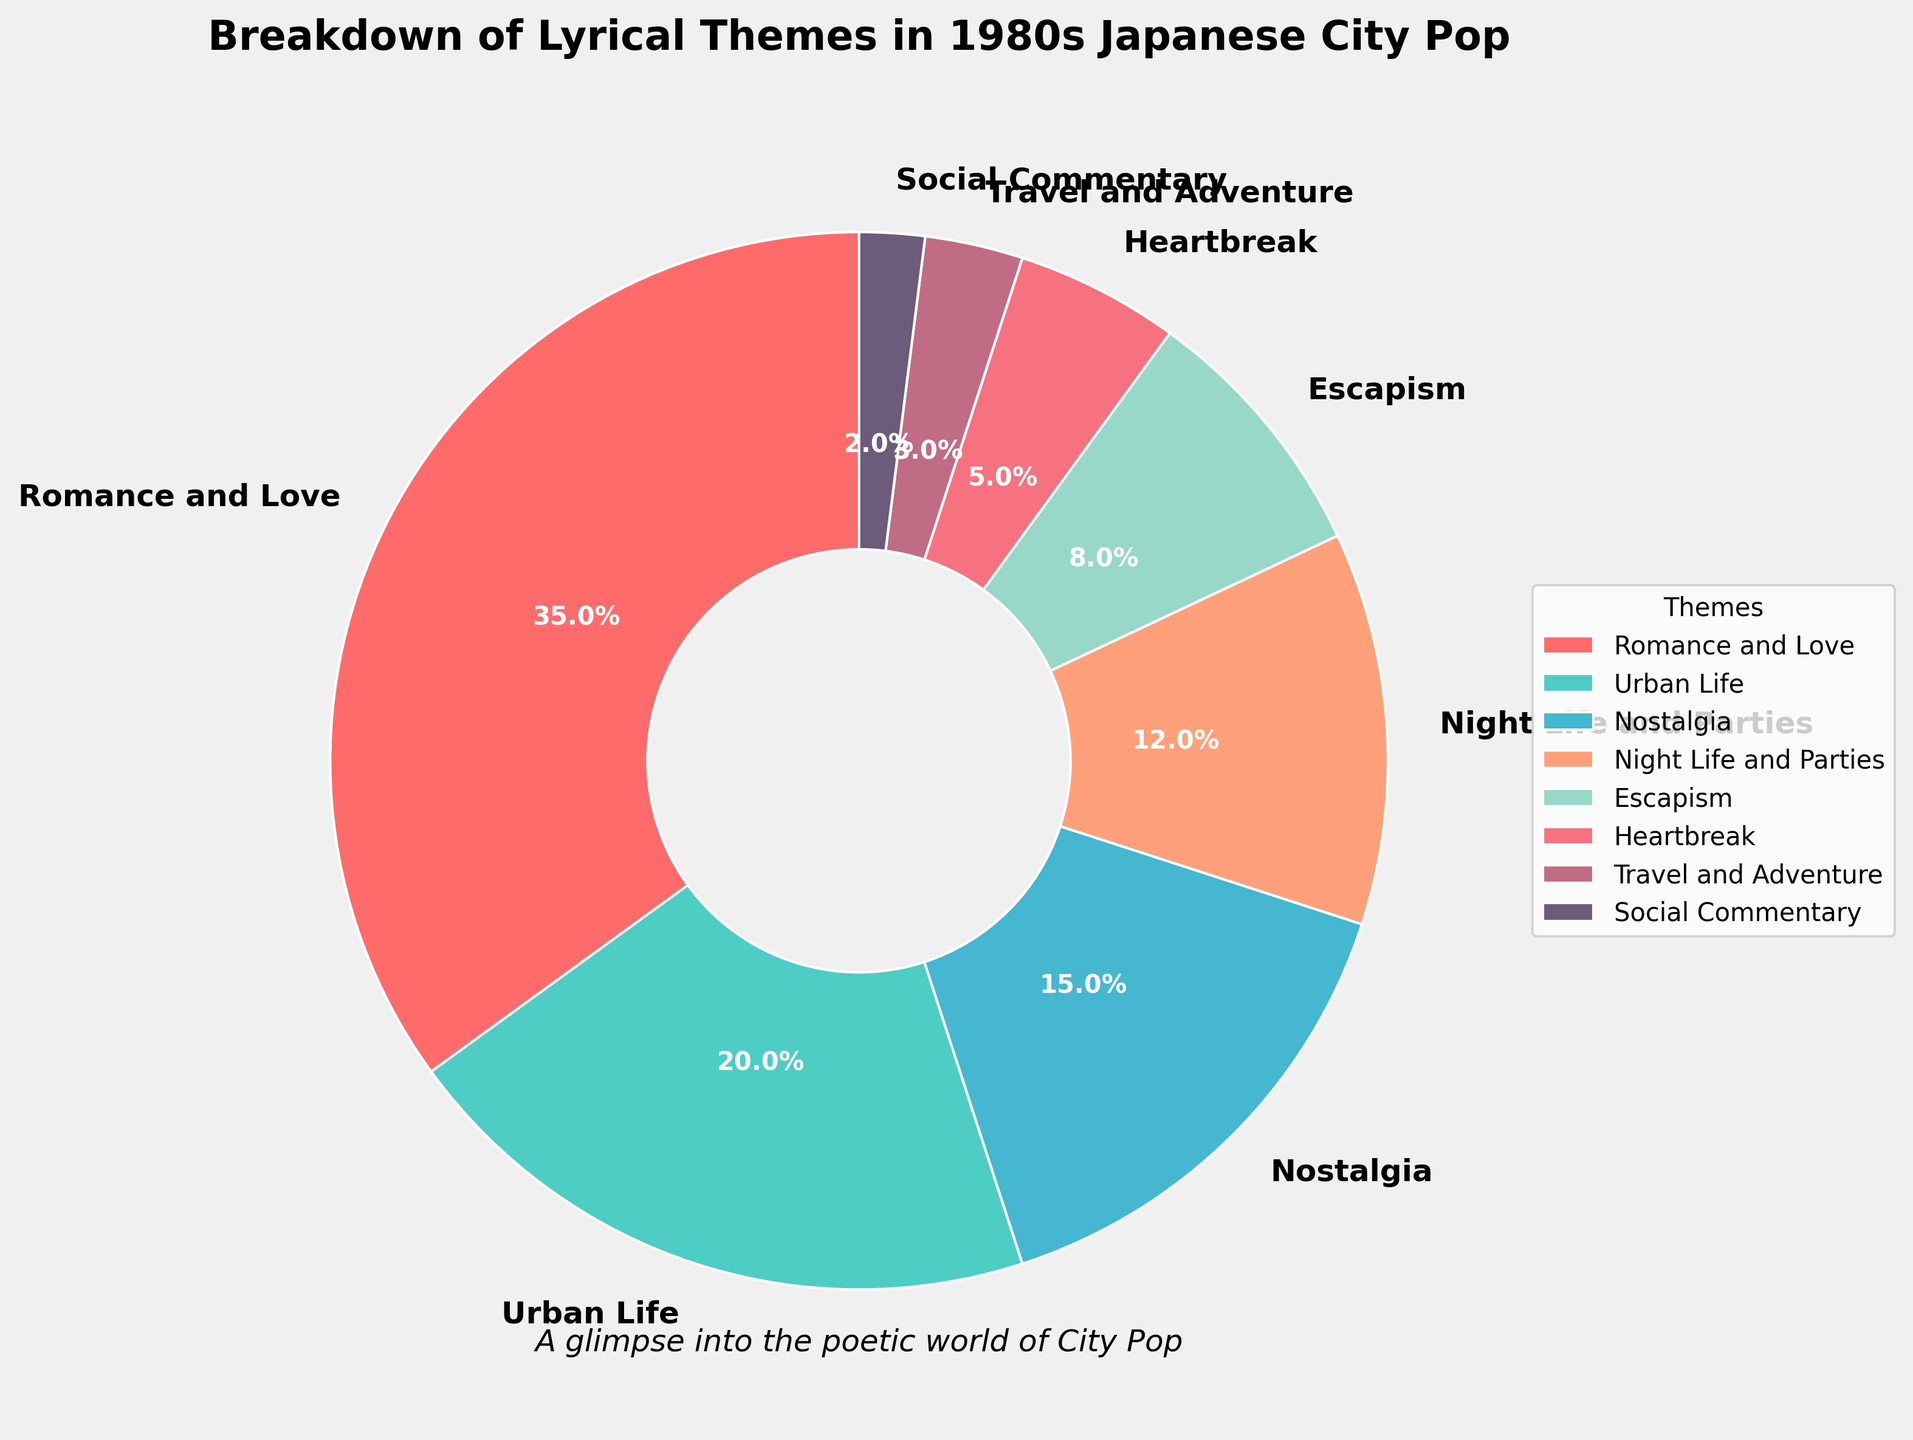What percentage of the lyrical themes are related to both Urban Life and Social Commentary combined? Add the percentages for Urban Life (20%) and Social Commentary (2%). So, 20% + 2% = 22%.
Answer: 22% Which theme has a smaller percentage, Heartbreak or Travel and Adventure? Compare the percentages for Heartbreak (5%) and Travel and Adventure (3%). Travel and Adventure has a smaller percentage.
Answer: Travel and Adventure How much more prominent is Romance and Love compared to Heartbreak? Subtract the percentage of Heartbreak (5%) from Romance and Love (35%). So, 35% - 5% = 30%.
Answer: 30% What is the total percentage for themes related to Night Life and Parties, and Escapism? Add the percentages for Night Life and Parties (12%) and Escapism (8%). So, 12% + 8% = 20%.
Answer: 20% Which theme has twice the percentage of Escapism, and what is the percentage difference between them? Urban Life has twice the percentage of Escapism. Escapism is 8%, and Urban Life is 20%. The percentage difference: 20% - 8% = 12%.
Answer: Urban Life, 12% Are there more songs themed around Nostalgia or Travel and Adventure? Compare the percentages for Nostalgia (15%) and Travel and Adventure (3%). Nostalgia has a higher percentage.
Answer: Nostalgia Which lyrical theme is least common in city pop songs according to the pie chart? Identify the theme with the smallest percentage value in the chart. Social Commentary is 2%, the lowest.
Answer: Social Commentary What is the ratio of songs about Romance and Love to those about Heartbreak? Divide the percentage for Romance and Love (35%) by Heartbreak (5%). The ratio is 35 / 5 = 7.
Answer: 7 How many themes have a percentage higher than 10%? Count the themes with percentages greater than 10%: Romance and Love (35%), Urban Life (20%), Nostalgia (15%), Night Life and Parties (12%). There are 4 themes.
Answer: 4 Is the percentage of songs themed around Night Life and Parties greater than the combined percentage of Travel and Adventure, and Social Commentary? Add the percentages for Travel and Adventure (3%) and Social Commentary (2%). Their combined percentage is 3% + 2% = 5%. Compare it with Night Life and Parties (12%). Yes, Night Life and Parties (12%) is greater than the combined percentage (5%).
Answer: Yes 